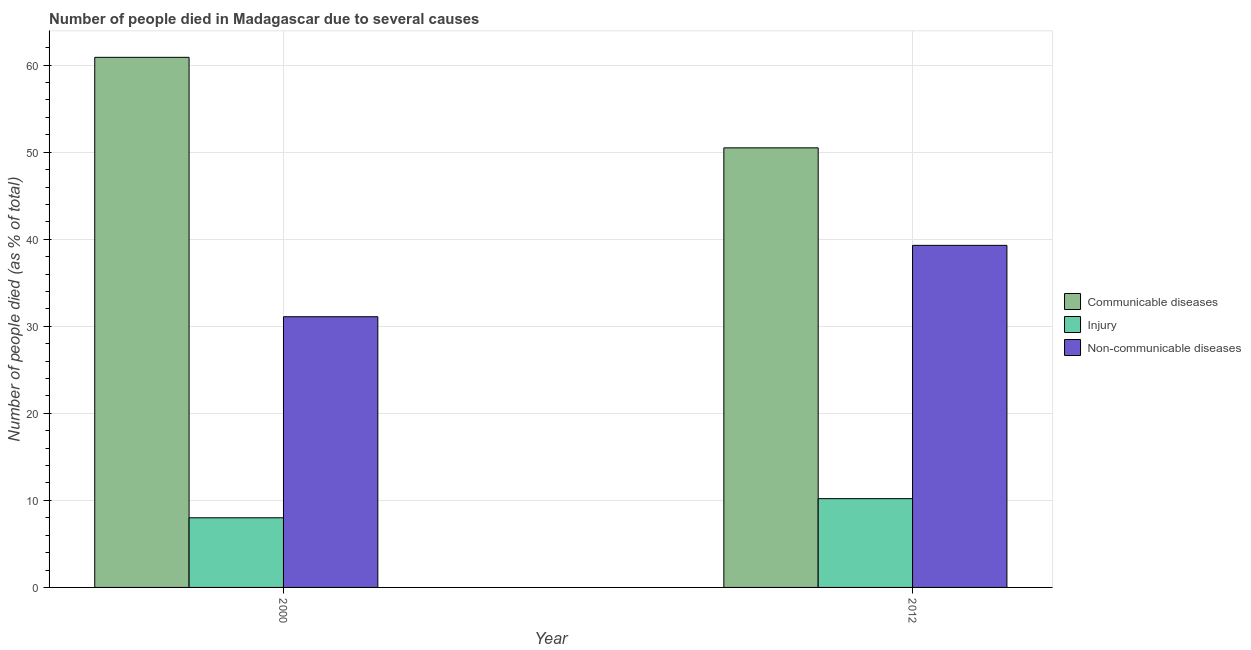How many different coloured bars are there?
Provide a short and direct response. 3. How many groups of bars are there?
Your answer should be compact. 2. How many bars are there on the 2nd tick from the left?
Your answer should be very brief. 3. What is the label of the 1st group of bars from the left?
Ensure brevity in your answer.  2000. In how many cases, is the number of bars for a given year not equal to the number of legend labels?
Ensure brevity in your answer.  0. What is the number of people who died of communicable diseases in 2012?
Keep it short and to the point. 50.5. Across all years, what is the maximum number of people who died of communicable diseases?
Offer a very short reply. 60.9. Across all years, what is the minimum number of people who died of communicable diseases?
Ensure brevity in your answer.  50.5. In which year was the number of people who dies of non-communicable diseases maximum?
Keep it short and to the point. 2012. In which year was the number of people who died of injury minimum?
Provide a short and direct response. 2000. What is the difference between the number of people who died of communicable diseases in 2000 and that in 2012?
Ensure brevity in your answer.  10.4. What is the difference between the number of people who died of communicable diseases in 2000 and the number of people who dies of non-communicable diseases in 2012?
Provide a short and direct response. 10.4. What is the average number of people who died of injury per year?
Your answer should be very brief. 9.1. In how many years, is the number of people who died of communicable diseases greater than 58 %?
Ensure brevity in your answer.  1. What is the ratio of the number of people who dies of non-communicable diseases in 2000 to that in 2012?
Offer a terse response. 0.79. In how many years, is the number of people who died of injury greater than the average number of people who died of injury taken over all years?
Ensure brevity in your answer.  1. What does the 2nd bar from the left in 2000 represents?
Offer a terse response. Injury. What does the 3rd bar from the right in 2012 represents?
Give a very brief answer. Communicable diseases. Is it the case that in every year, the sum of the number of people who died of communicable diseases and number of people who died of injury is greater than the number of people who dies of non-communicable diseases?
Keep it short and to the point. Yes. How many bars are there?
Your response must be concise. 6. Are all the bars in the graph horizontal?
Offer a very short reply. No. How many years are there in the graph?
Offer a terse response. 2. What is the difference between two consecutive major ticks on the Y-axis?
Provide a short and direct response. 10. Does the graph contain grids?
Ensure brevity in your answer.  Yes. What is the title of the graph?
Ensure brevity in your answer.  Number of people died in Madagascar due to several causes. Does "Taxes" appear as one of the legend labels in the graph?
Provide a short and direct response. No. What is the label or title of the X-axis?
Ensure brevity in your answer.  Year. What is the label or title of the Y-axis?
Your response must be concise. Number of people died (as % of total). What is the Number of people died (as % of total) in Communicable diseases in 2000?
Ensure brevity in your answer.  60.9. What is the Number of people died (as % of total) in Injury in 2000?
Offer a terse response. 8. What is the Number of people died (as % of total) in Non-communicable diseases in 2000?
Give a very brief answer. 31.1. What is the Number of people died (as % of total) of Communicable diseases in 2012?
Make the answer very short. 50.5. What is the Number of people died (as % of total) in Non-communicable diseases in 2012?
Give a very brief answer. 39.3. Across all years, what is the maximum Number of people died (as % of total) in Communicable diseases?
Offer a very short reply. 60.9. Across all years, what is the maximum Number of people died (as % of total) of Non-communicable diseases?
Make the answer very short. 39.3. Across all years, what is the minimum Number of people died (as % of total) in Communicable diseases?
Provide a short and direct response. 50.5. Across all years, what is the minimum Number of people died (as % of total) in Non-communicable diseases?
Provide a succinct answer. 31.1. What is the total Number of people died (as % of total) in Communicable diseases in the graph?
Your answer should be compact. 111.4. What is the total Number of people died (as % of total) in Non-communicable diseases in the graph?
Offer a very short reply. 70.4. What is the difference between the Number of people died (as % of total) in Communicable diseases in 2000 and that in 2012?
Your answer should be very brief. 10.4. What is the difference between the Number of people died (as % of total) in Non-communicable diseases in 2000 and that in 2012?
Give a very brief answer. -8.2. What is the difference between the Number of people died (as % of total) in Communicable diseases in 2000 and the Number of people died (as % of total) in Injury in 2012?
Make the answer very short. 50.7. What is the difference between the Number of people died (as % of total) in Communicable diseases in 2000 and the Number of people died (as % of total) in Non-communicable diseases in 2012?
Provide a short and direct response. 21.6. What is the difference between the Number of people died (as % of total) in Injury in 2000 and the Number of people died (as % of total) in Non-communicable diseases in 2012?
Your answer should be very brief. -31.3. What is the average Number of people died (as % of total) of Communicable diseases per year?
Give a very brief answer. 55.7. What is the average Number of people died (as % of total) of Non-communicable diseases per year?
Offer a very short reply. 35.2. In the year 2000, what is the difference between the Number of people died (as % of total) of Communicable diseases and Number of people died (as % of total) of Injury?
Keep it short and to the point. 52.9. In the year 2000, what is the difference between the Number of people died (as % of total) of Communicable diseases and Number of people died (as % of total) of Non-communicable diseases?
Provide a short and direct response. 29.8. In the year 2000, what is the difference between the Number of people died (as % of total) of Injury and Number of people died (as % of total) of Non-communicable diseases?
Ensure brevity in your answer.  -23.1. In the year 2012, what is the difference between the Number of people died (as % of total) in Communicable diseases and Number of people died (as % of total) in Injury?
Make the answer very short. 40.3. In the year 2012, what is the difference between the Number of people died (as % of total) in Injury and Number of people died (as % of total) in Non-communicable diseases?
Your response must be concise. -29.1. What is the ratio of the Number of people died (as % of total) in Communicable diseases in 2000 to that in 2012?
Make the answer very short. 1.21. What is the ratio of the Number of people died (as % of total) in Injury in 2000 to that in 2012?
Offer a terse response. 0.78. What is the ratio of the Number of people died (as % of total) in Non-communicable diseases in 2000 to that in 2012?
Keep it short and to the point. 0.79. What is the difference between the highest and the second highest Number of people died (as % of total) of Injury?
Ensure brevity in your answer.  2.2. What is the difference between the highest and the lowest Number of people died (as % of total) of Communicable diseases?
Ensure brevity in your answer.  10.4. What is the difference between the highest and the lowest Number of people died (as % of total) of Injury?
Ensure brevity in your answer.  2.2. What is the difference between the highest and the lowest Number of people died (as % of total) of Non-communicable diseases?
Give a very brief answer. 8.2. 